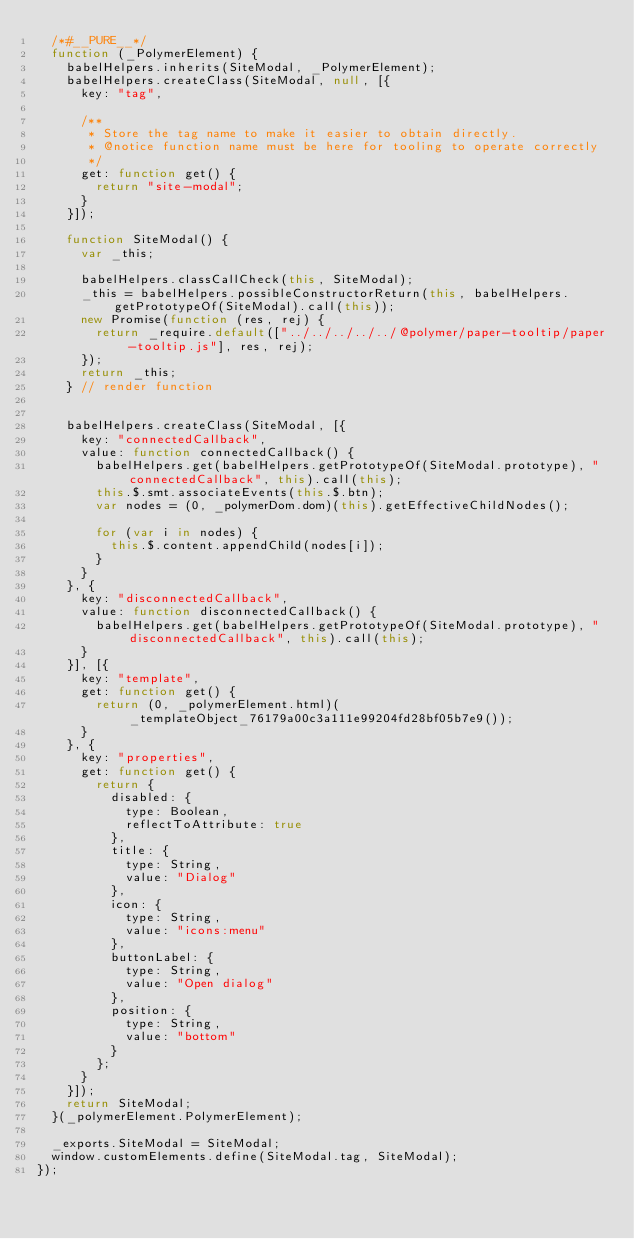Convert code to text. <code><loc_0><loc_0><loc_500><loc_500><_JavaScript_>  /*#__PURE__*/
  function (_PolymerElement) {
    babelHelpers.inherits(SiteModal, _PolymerElement);
    babelHelpers.createClass(SiteModal, null, [{
      key: "tag",

      /**
       * Store the tag name to make it easier to obtain directly.
       * @notice function name must be here for tooling to operate correctly
       */
      get: function get() {
        return "site-modal";
      }
    }]);

    function SiteModal() {
      var _this;

      babelHelpers.classCallCheck(this, SiteModal);
      _this = babelHelpers.possibleConstructorReturn(this, babelHelpers.getPrototypeOf(SiteModal).call(this));
      new Promise(function (res, rej) {
        return _require.default(["../../../../../@polymer/paper-tooltip/paper-tooltip.js"], res, rej);
      });
      return _this;
    } // render function


    babelHelpers.createClass(SiteModal, [{
      key: "connectedCallback",
      value: function connectedCallback() {
        babelHelpers.get(babelHelpers.getPrototypeOf(SiteModal.prototype), "connectedCallback", this).call(this);
        this.$.smt.associateEvents(this.$.btn);
        var nodes = (0, _polymerDom.dom)(this).getEffectiveChildNodes();

        for (var i in nodes) {
          this.$.content.appendChild(nodes[i]);
        }
      }
    }, {
      key: "disconnectedCallback",
      value: function disconnectedCallback() {
        babelHelpers.get(babelHelpers.getPrototypeOf(SiteModal.prototype), "disconnectedCallback", this).call(this);
      }
    }], [{
      key: "template",
      get: function get() {
        return (0, _polymerElement.html)(_templateObject_76179a00c3a111e99204fd28bf05b7e9());
      }
    }, {
      key: "properties",
      get: function get() {
        return {
          disabled: {
            type: Boolean,
            reflectToAttribute: true
          },
          title: {
            type: String,
            value: "Dialog"
          },
          icon: {
            type: String,
            value: "icons:menu"
          },
          buttonLabel: {
            type: String,
            value: "Open dialog"
          },
          position: {
            type: String,
            value: "bottom"
          }
        };
      }
    }]);
    return SiteModal;
  }(_polymerElement.PolymerElement);

  _exports.SiteModal = SiteModal;
  window.customElements.define(SiteModal.tag, SiteModal);
});</code> 